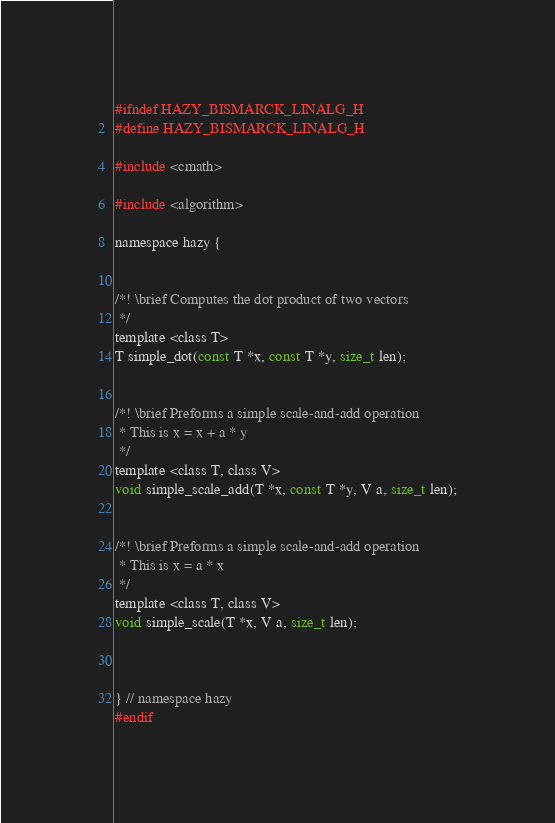<code> <loc_0><loc_0><loc_500><loc_500><_C_>
#ifndef HAZY_BISMARCK_LINALG_H
#define HAZY_BISMARCK_LINALG_H

#include <cmath>

#include <algorithm>

namespace hazy {


/*! \brief Computes the dot product of two vectors
 */
template <class T>
T simple_dot(const T *x, const T *y, size_t len);


/*! \brief Preforms a simple scale-and-add operation
 * This is x = x + a * y
 */
template <class T, class V>
void simple_scale_add(T *x, const T *y, V a, size_t len);


/*! \brief Preforms a simple scale-and-add operation
 * This is x = a * x 
 */
template <class T, class V>
void simple_scale(T *x, V a, size_t len);



} // namespace hazy
#endif

</code> 